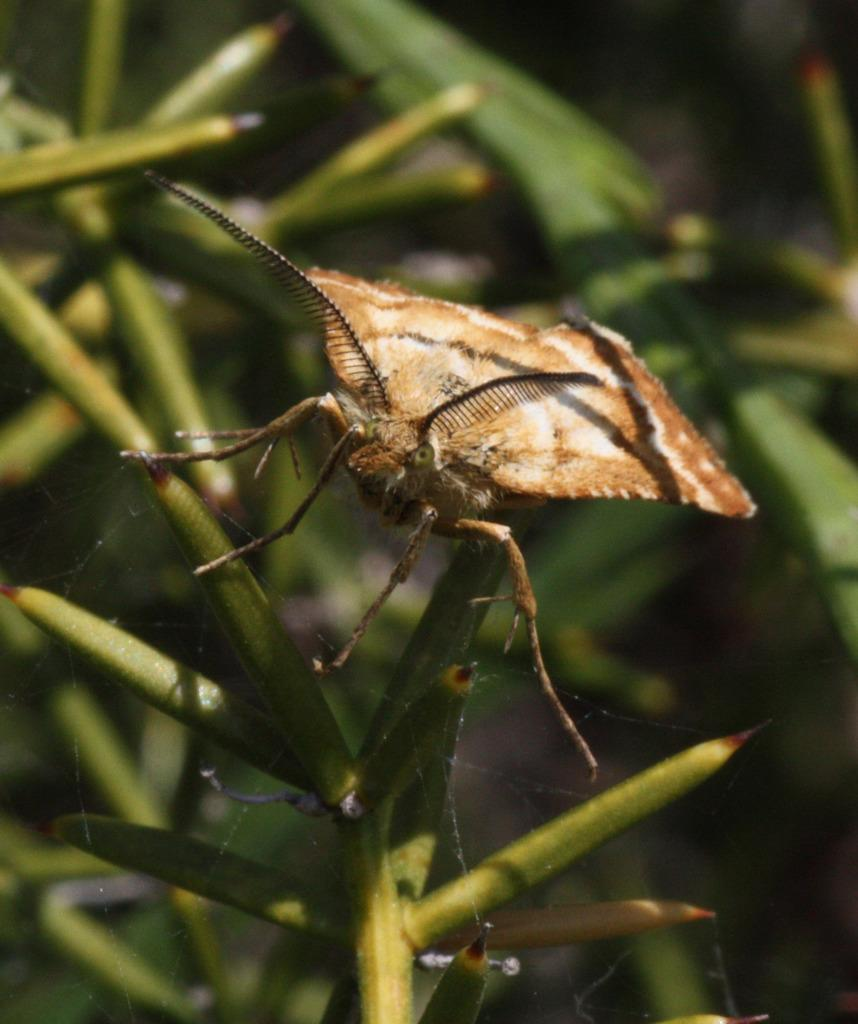What is present in the foreground of the image? There is an insect on a plant in the foreground of the image. What can be seen in the background of the image? There is a plant visible in the background of the image. How many plants are visible in the image? There are at least two plants visible in the image, one in the foreground and one in the background. What type of voice can be heard coming from the insect in the image? Insects do not have the ability to produce a voice, so there is no voice coming from the insect in the image. 